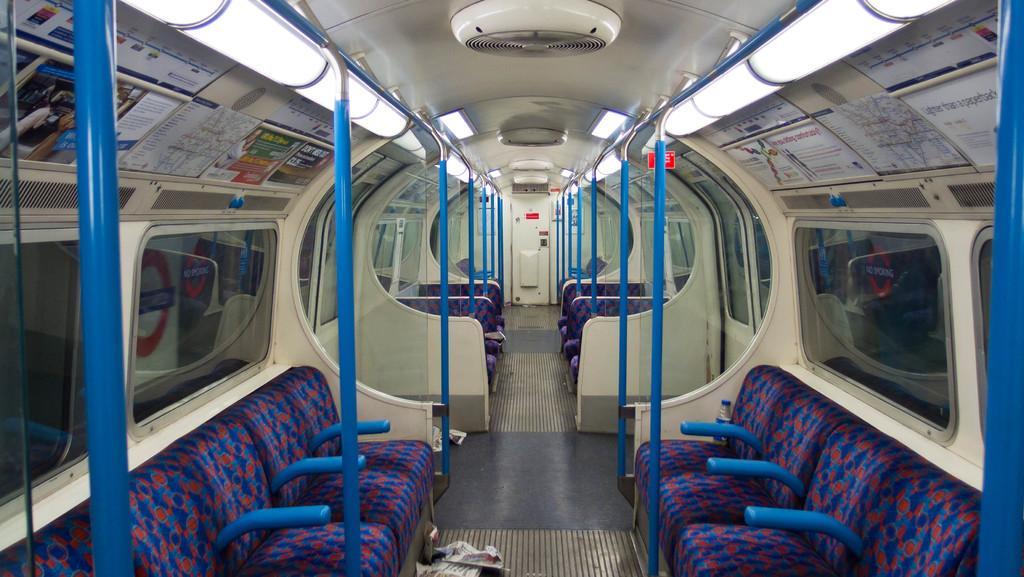How would you summarize this image in a sentence or two? In this image I can see the inner part of the train. I can also see few chairs, poles in blue color, left and right I can see glass windows and lights. 